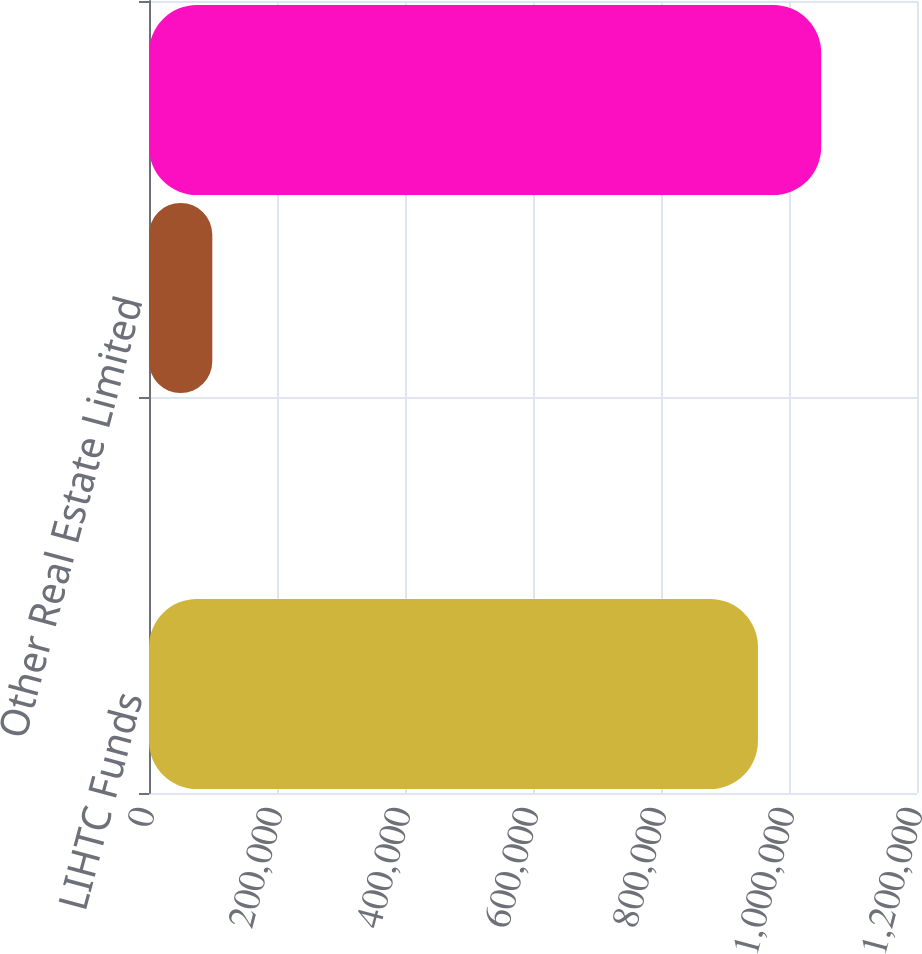<chart> <loc_0><loc_0><loc_500><loc_500><bar_chart><fcel>LIHTC Funds<fcel>NMTC Funds<fcel>Other Real Estate Limited<fcel>Total<nl><fcel>951465<fcel>40<fcel>98892.7<fcel>1.05032e+06<nl></chart> 